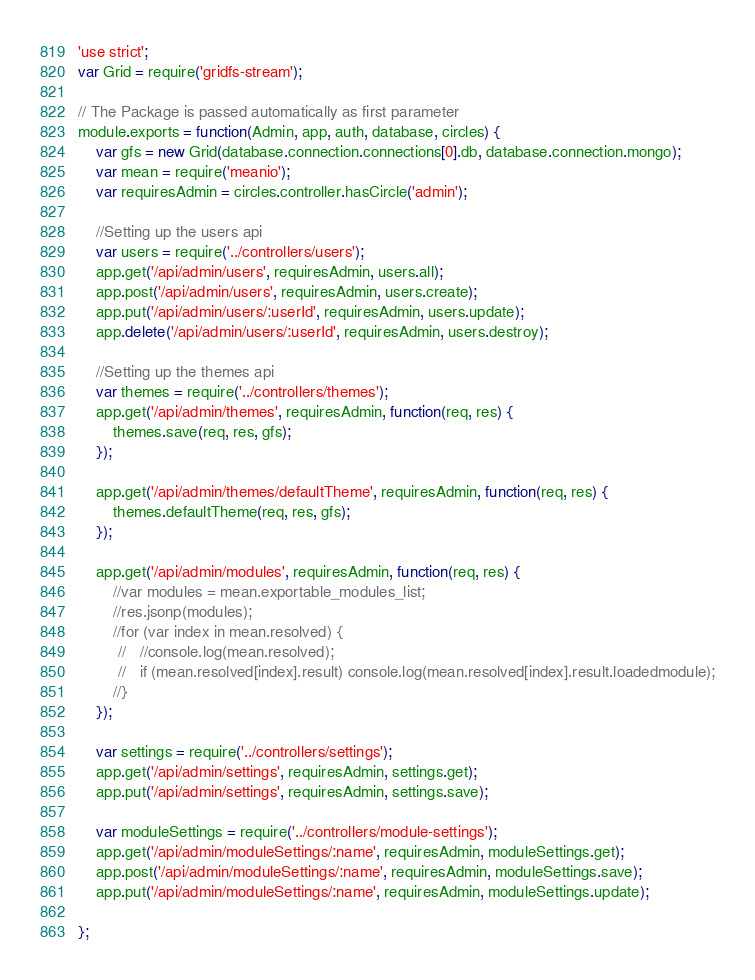<code> <loc_0><loc_0><loc_500><loc_500><_JavaScript_>'use strict';
var Grid = require('gridfs-stream');

// The Package is passed automatically as first parameter
module.exports = function(Admin, app, auth, database, circles) {
    var gfs = new Grid(database.connection.connections[0].db, database.connection.mongo);
    var mean = require('meanio');
    var requiresAdmin = circles.controller.hasCircle('admin');

    //Setting up the users api
    var users = require('../controllers/users');
    app.get('/api/admin/users', requiresAdmin, users.all);
    app.post('/api/admin/users', requiresAdmin, users.create);
    app.put('/api/admin/users/:userId', requiresAdmin, users.update);
    app.delete('/api/admin/users/:userId', requiresAdmin, users.destroy);

    //Setting up the themes api
    var themes = require('../controllers/themes');
    app.get('/api/admin/themes', requiresAdmin, function(req, res) {
        themes.save(req, res, gfs);
    });

    app.get('/api/admin/themes/defaultTheme', requiresAdmin, function(req, res) {
        themes.defaultTheme(req, res, gfs);
    });

    app.get('/api/admin/modules', requiresAdmin, function(req, res) {
	    //var modules = mean.exportable_modules_list;
	    //res.jsonp(modules);
	    //for (var index in mean.resolved) {
		 //   //console.log(mean.resolved);
		 //   if (mean.resolved[index].result) console.log(mean.resolved[index].result.loadedmodule);
	    //}
    });

    var settings = require('../controllers/settings');
    app.get('/api/admin/settings', requiresAdmin, settings.get);
    app.put('/api/admin/settings', requiresAdmin, settings.save);

	var moduleSettings = require('../controllers/module-settings');
	app.get('/api/admin/moduleSettings/:name', requiresAdmin, moduleSettings.get);
	app.post('/api/admin/moduleSettings/:name', requiresAdmin, moduleSettings.save);
	app.put('/api/admin/moduleSettings/:name', requiresAdmin, moduleSettings.update);

};
</code> 